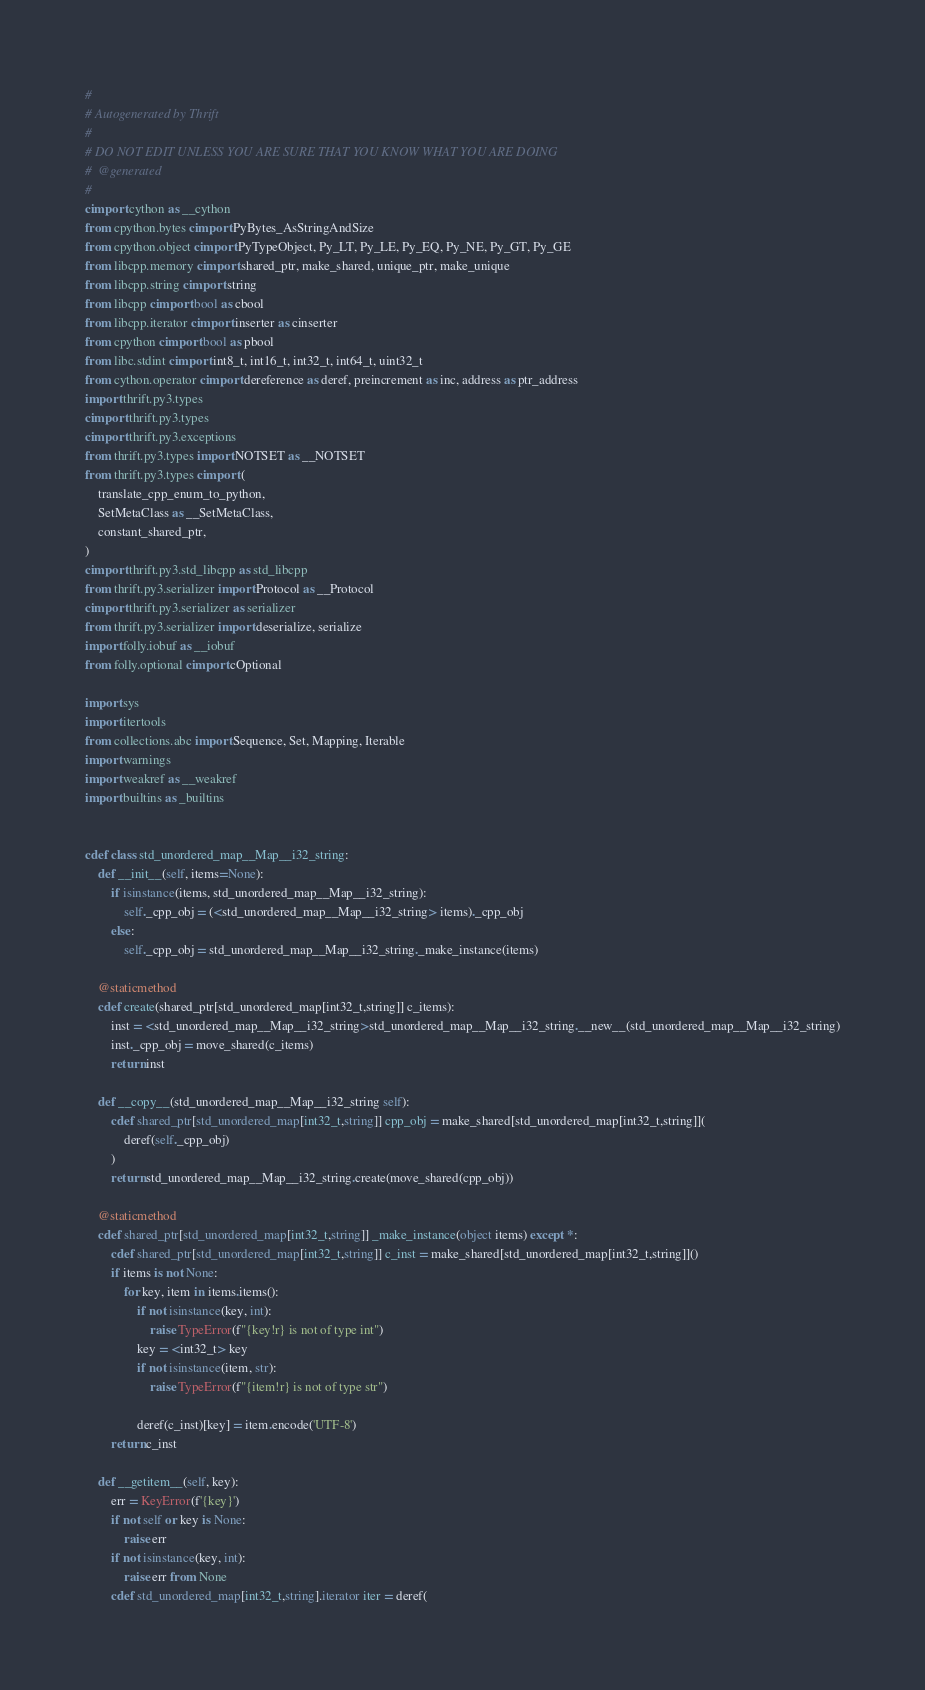Convert code to text. <code><loc_0><loc_0><loc_500><loc_500><_Cython_>#
# Autogenerated by Thrift
#
# DO NOT EDIT UNLESS YOU ARE SURE THAT YOU KNOW WHAT YOU ARE DOING
#  @generated
#
cimport cython as __cython
from cpython.bytes cimport PyBytes_AsStringAndSize
from cpython.object cimport PyTypeObject, Py_LT, Py_LE, Py_EQ, Py_NE, Py_GT, Py_GE
from libcpp.memory cimport shared_ptr, make_shared, unique_ptr, make_unique
from libcpp.string cimport string
from libcpp cimport bool as cbool
from libcpp.iterator cimport inserter as cinserter
from cpython cimport bool as pbool
from libc.stdint cimport int8_t, int16_t, int32_t, int64_t, uint32_t
from cython.operator cimport dereference as deref, preincrement as inc, address as ptr_address
import thrift.py3.types
cimport thrift.py3.types
cimport thrift.py3.exceptions
from thrift.py3.types import NOTSET as __NOTSET
from thrift.py3.types cimport (
    translate_cpp_enum_to_python,
    SetMetaClass as __SetMetaClass,
    constant_shared_ptr,
)
cimport thrift.py3.std_libcpp as std_libcpp
from thrift.py3.serializer import Protocol as __Protocol
cimport thrift.py3.serializer as serializer
from thrift.py3.serializer import deserialize, serialize
import folly.iobuf as __iobuf
from folly.optional cimport cOptional

import sys
import itertools
from collections.abc import Sequence, Set, Mapping, Iterable
import warnings
import weakref as __weakref
import builtins as _builtins


cdef class std_unordered_map__Map__i32_string:
    def __init__(self, items=None):
        if isinstance(items, std_unordered_map__Map__i32_string):
            self._cpp_obj = (<std_unordered_map__Map__i32_string> items)._cpp_obj
        else:
            self._cpp_obj = std_unordered_map__Map__i32_string._make_instance(items)

    @staticmethod
    cdef create(shared_ptr[std_unordered_map[int32_t,string]] c_items):
        inst = <std_unordered_map__Map__i32_string>std_unordered_map__Map__i32_string.__new__(std_unordered_map__Map__i32_string)
        inst._cpp_obj = move_shared(c_items)
        return inst

    def __copy__(std_unordered_map__Map__i32_string self):
        cdef shared_ptr[std_unordered_map[int32_t,string]] cpp_obj = make_shared[std_unordered_map[int32_t,string]](
            deref(self._cpp_obj)
        )
        return std_unordered_map__Map__i32_string.create(move_shared(cpp_obj))

    @staticmethod
    cdef shared_ptr[std_unordered_map[int32_t,string]] _make_instance(object items) except *:
        cdef shared_ptr[std_unordered_map[int32_t,string]] c_inst = make_shared[std_unordered_map[int32_t,string]]()
        if items is not None:
            for key, item in items.items():
                if not isinstance(key, int):
                    raise TypeError(f"{key!r} is not of type int")
                key = <int32_t> key
                if not isinstance(item, str):
                    raise TypeError(f"{item!r} is not of type str")

                deref(c_inst)[key] = item.encode('UTF-8')
        return c_inst

    def __getitem__(self, key):
        err = KeyError(f'{key}')
        if not self or key is None:
            raise err
        if not isinstance(key, int):
            raise err from None
        cdef std_unordered_map[int32_t,string].iterator iter = deref(</code> 